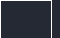<code> <loc_0><loc_0><loc_500><loc_500><_SQL_>
</code> 